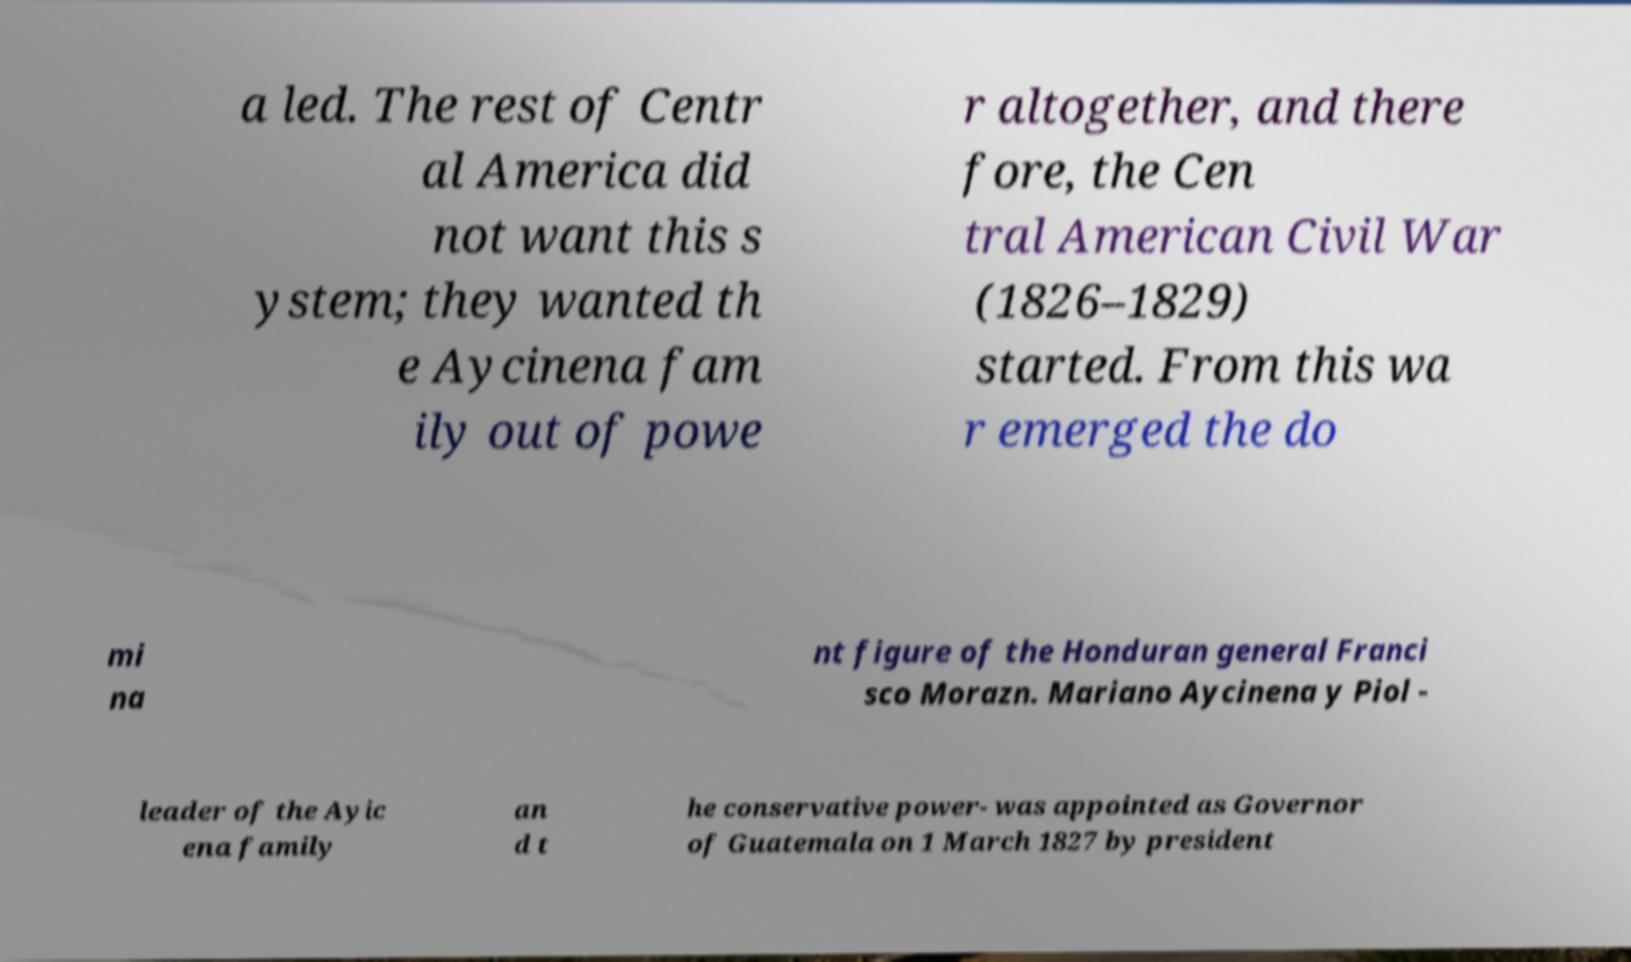There's text embedded in this image that I need extracted. Can you transcribe it verbatim? a led. The rest of Centr al America did not want this s ystem; they wanted th e Aycinena fam ily out of powe r altogether, and there fore, the Cen tral American Civil War (1826–1829) started. From this wa r emerged the do mi na nt figure of the Honduran general Franci sco Morazn. Mariano Aycinena y Piol - leader of the Ayic ena family an d t he conservative power- was appointed as Governor of Guatemala on 1 March 1827 by president 